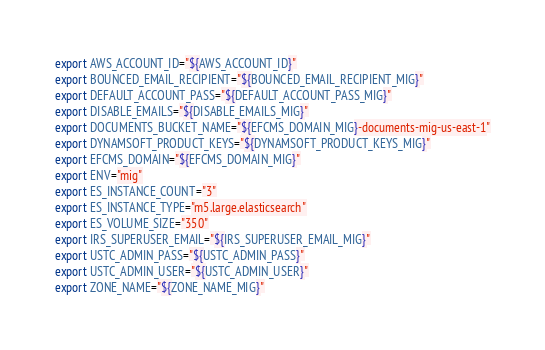<code> <loc_0><loc_0><loc_500><loc_500><_Bash_>export AWS_ACCOUNT_ID="${AWS_ACCOUNT_ID}"
export BOUNCED_EMAIL_RECIPIENT="${BOUNCED_EMAIL_RECIPIENT_MIG}"
export DEFAULT_ACCOUNT_PASS="${DEFAULT_ACCOUNT_PASS_MIG}"
export DISABLE_EMAILS="${DISABLE_EMAILS_MIG}"
export DOCUMENTS_BUCKET_NAME="${EFCMS_DOMAIN_MIG}-documents-mig-us-east-1"
export DYNAMSOFT_PRODUCT_KEYS="${DYNAMSOFT_PRODUCT_KEYS_MIG}"
export EFCMS_DOMAIN="${EFCMS_DOMAIN_MIG}"
export ENV="mig"
export ES_INSTANCE_COUNT="3"
export ES_INSTANCE_TYPE="m5.large.elasticsearch"
export ES_VOLUME_SIZE="350"
export IRS_SUPERUSER_EMAIL="${IRS_SUPERUSER_EMAIL_MIG}"
export USTC_ADMIN_PASS="${USTC_ADMIN_PASS}"
export USTC_ADMIN_USER="${USTC_ADMIN_USER}"
export ZONE_NAME="${ZONE_NAME_MIG}"
</code> 